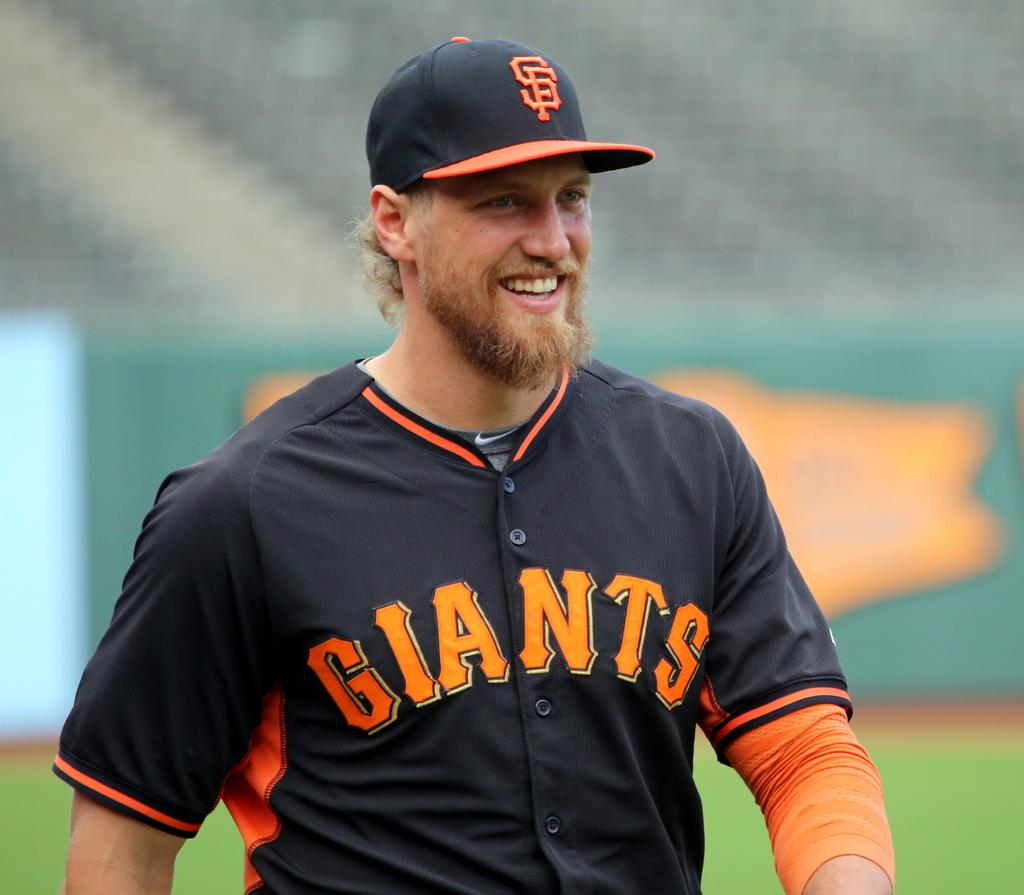<image>
Give a short and clear explanation of the subsequent image. A baseball played with a giants jersey is smiling 